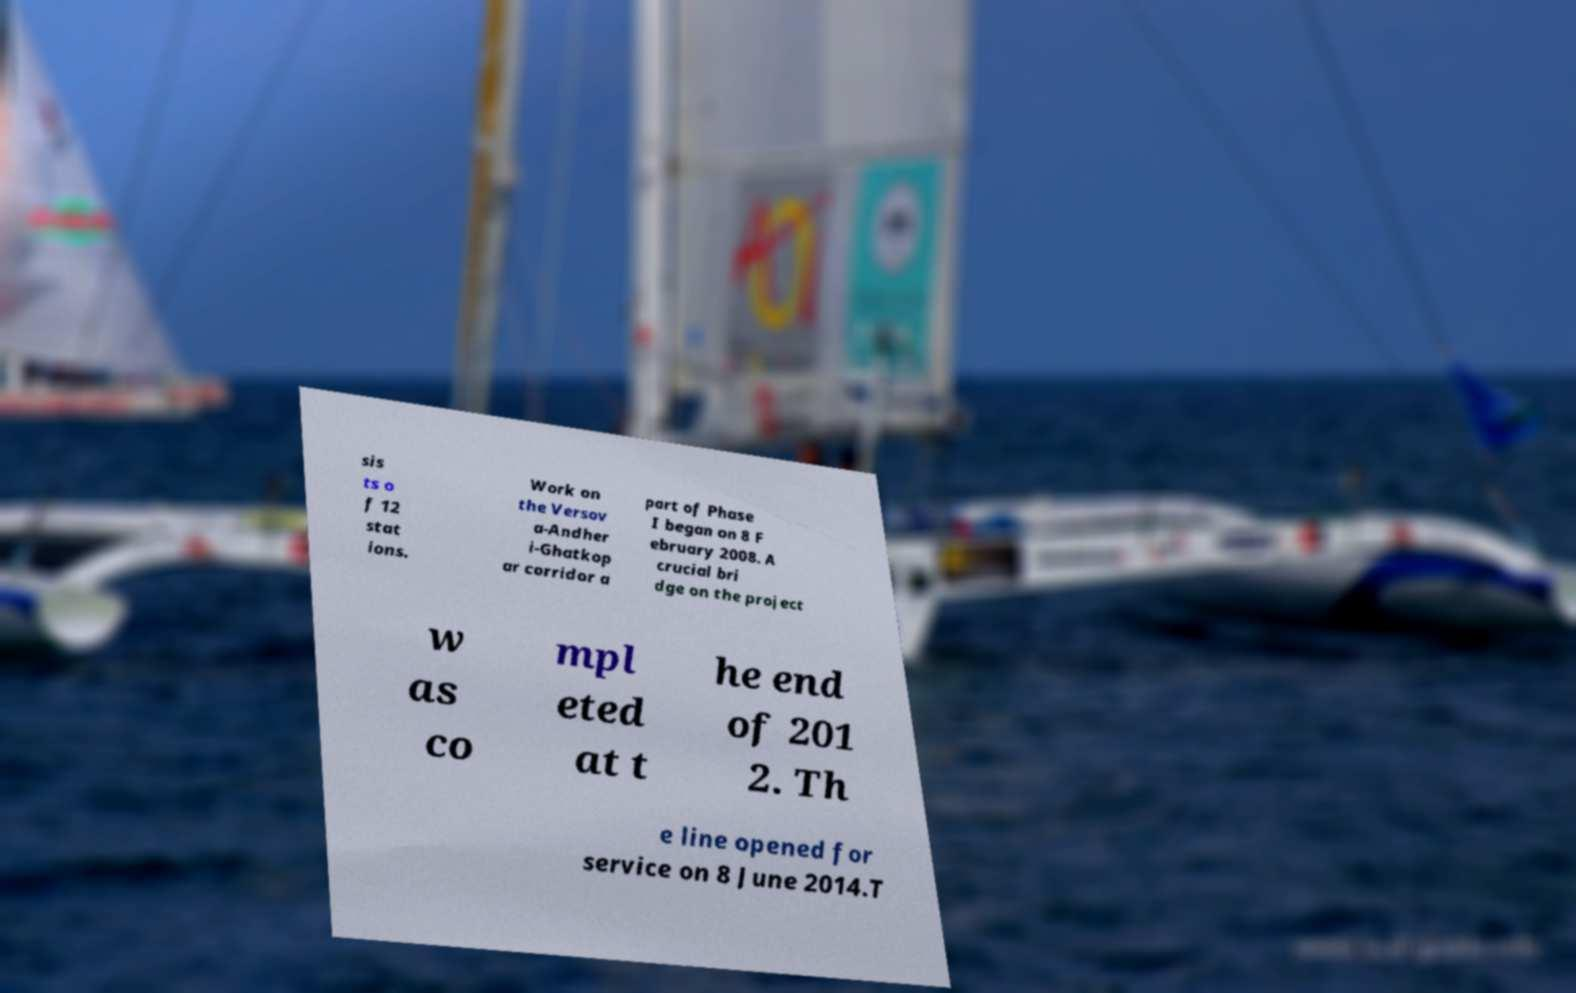Can you accurately transcribe the text from the provided image for me? sis ts o f 12 stat ions. Work on the Versov a-Andher i-Ghatkop ar corridor a part of Phase I began on 8 F ebruary 2008. A crucial bri dge on the project w as co mpl eted at t he end of 201 2. Th e line opened for service on 8 June 2014.T 